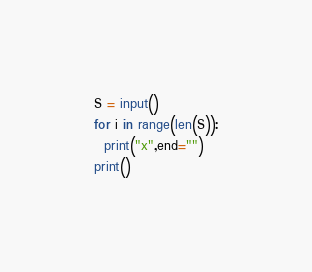Convert code to text. <code><loc_0><loc_0><loc_500><loc_500><_Python_>S = input()
for i in range(len(S)):
  print("x",end="")
print()</code> 